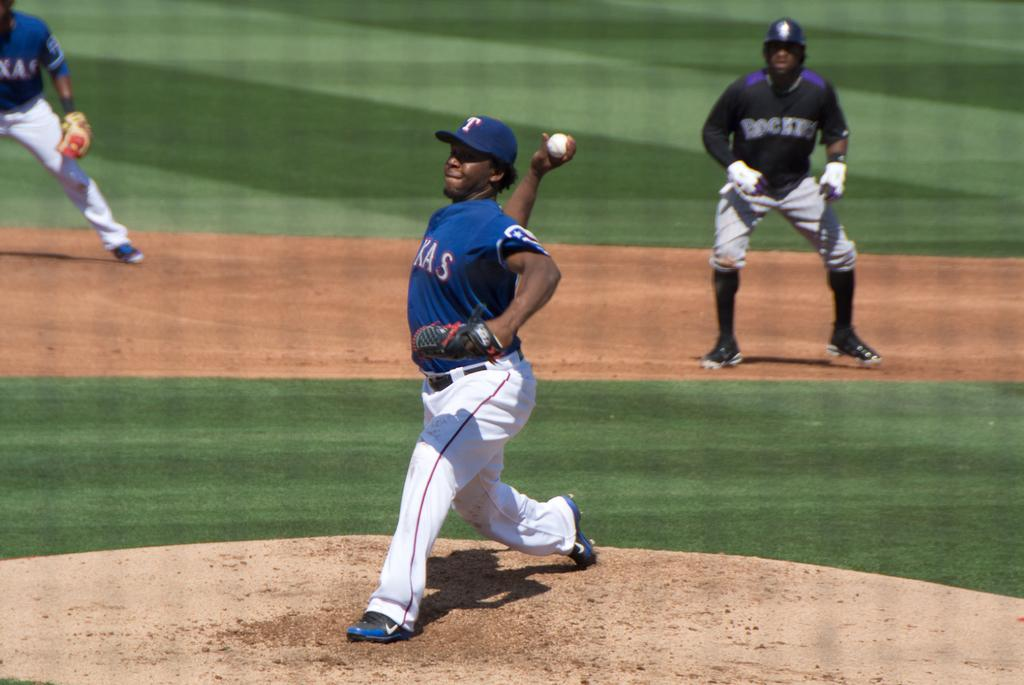<image>
Describe the image concisely. A player with a white T on his blue hat gets ready to throw a pitch 